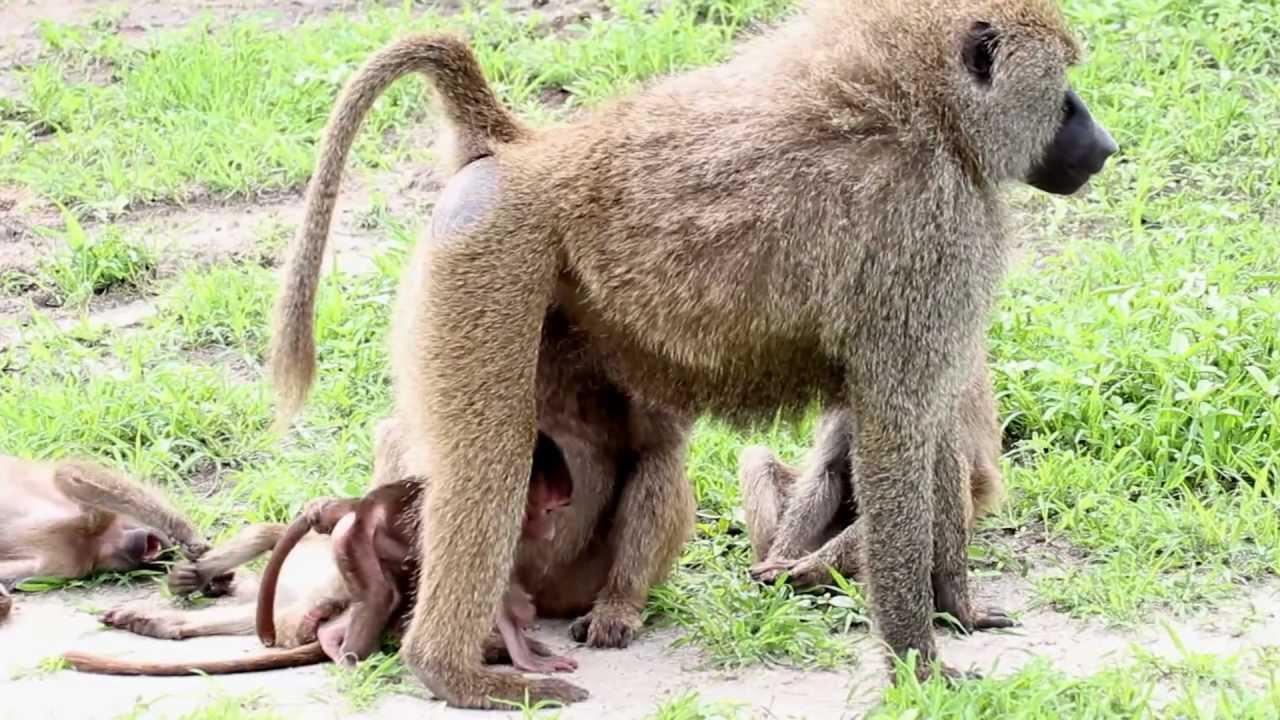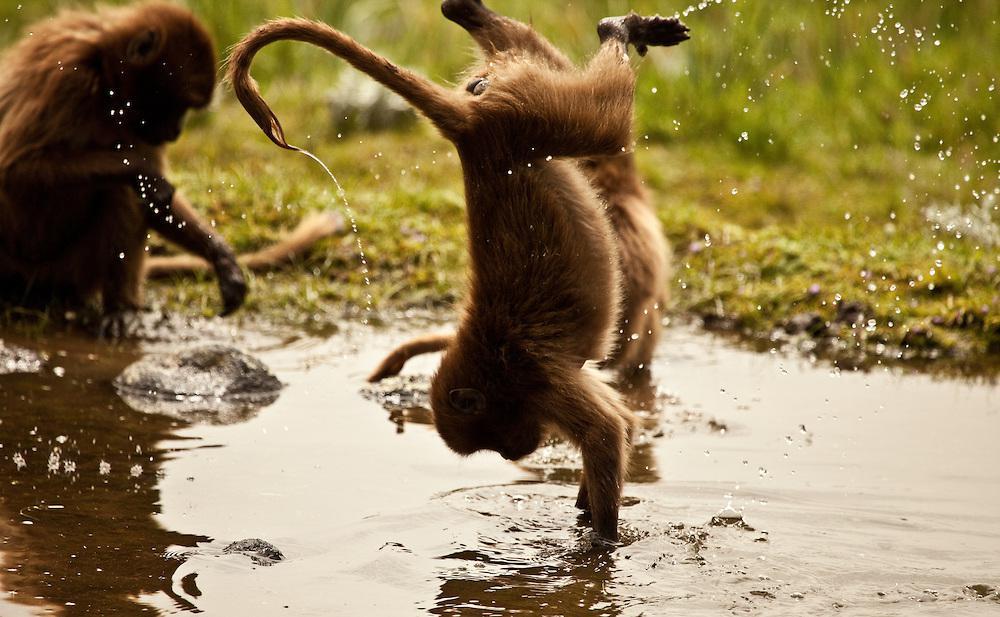The first image is the image on the left, the second image is the image on the right. Evaluate the accuracy of this statement regarding the images: "There are more than three, but no more than five monkeys.". Is it true? Answer yes or no. No. The first image is the image on the left, the second image is the image on the right. For the images displayed, is the sentence "Three monkeys are in a row on a rock in one image." factually correct? Answer yes or no. No. 